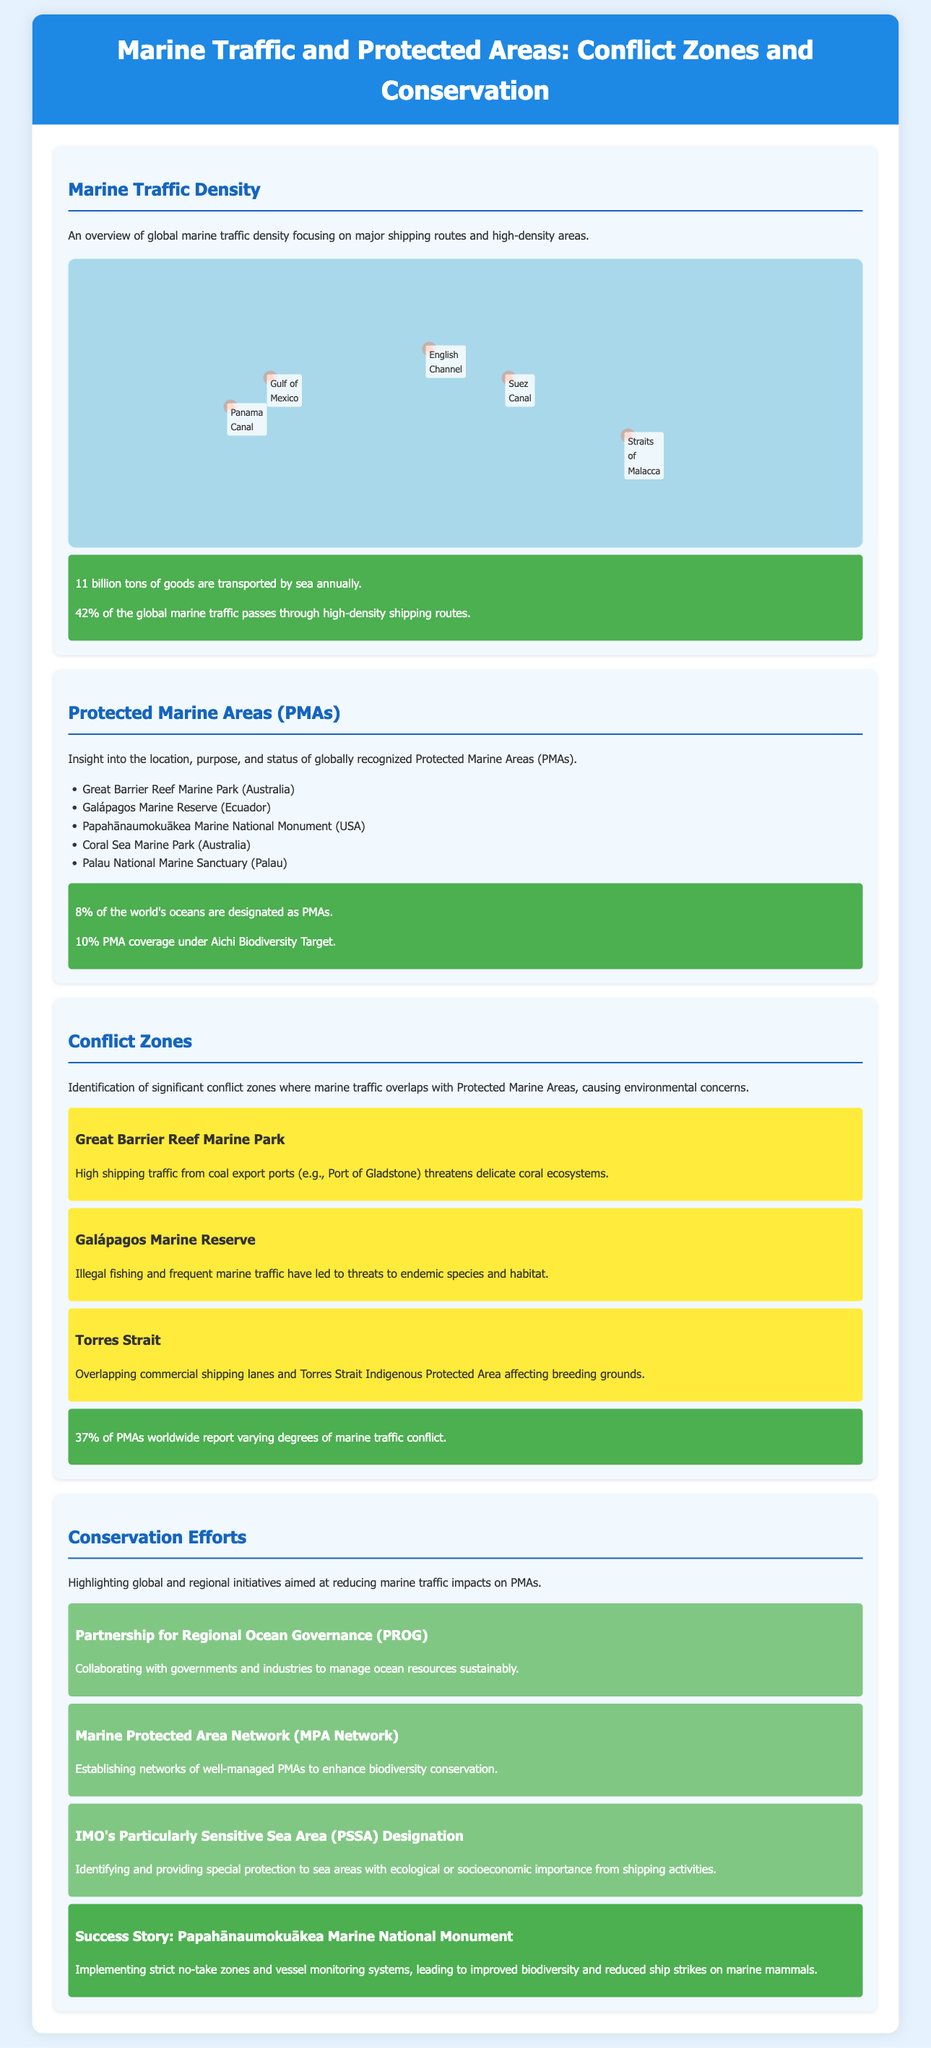What is the amount of goods transported by sea annually? The document states that 11 billion tons of goods are transported by sea annually.
Answer: 11 billion tons What is the percentage of the world's oceans designated as Protected Marine Areas? According to the document, 8% of the world's oceans are designated as PMAs.
Answer: 8% Which area reports high shipping traffic threatening coral ecosystems? The conflict zone section mentions that the Great Barrier Reef Marine Park faces high shipping traffic from coal export ports.
Answer: Great Barrier Reef Marine Park What does the acronym PSSA stand for in conservation efforts? The conservation efforts section refers to "Particularly Sensitive Sea Area" as PSSA.
Answer: Particularly Sensitive Sea Area How many PMAs worldwide report marine traffic conflict? The document indicates that 37% of PMAs worldwide report varying degrees of marine traffic conflict.
Answer: 37% What is a significant conservation initiative mentioned in the document? The document highlights "Partnership for Regional Ocean Governance (PROG)" as a significant conservation initiative.
Answer: Partnership for Regional Ocean Governance What is the purpose of the Marine Protected Area Network? The document states that the MPA Network aims to enhance biodiversity conservation by establishing networks of well-managed PMAs.
Answer: Enhance biodiversity conservation What type of document is presented here? This is a Geographic infographic analyzing marine traffic and protected areas, focusing on conflict zones and conservation efforts.
Answer: Geographic infographic 